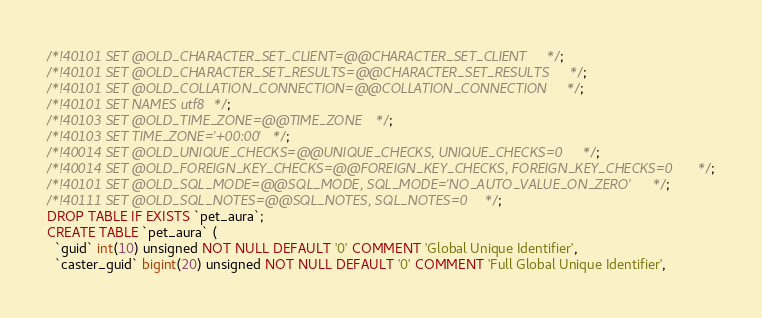<code> <loc_0><loc_0><loc_500><loc_500><_SQL_>
/*!40101 SET @OLD_CHARACTER_SET_CLIENT=@@CHARACTER_SET_CLIENT */;
/*!40101 SET @OLD_CHARACTER_SET_RESULTS=@@CHARACTER_SET_RESULTS */;
/*!40101 SET @OLD_COLLATION_CONNECTION=@@COLLATION_CONNECTION */;
/*!40101 SET NAMES utf8 */;
/*!40103 SET @OLD_TIME_ZONE=@@TIME_ZONE */;
/*!40103 SET TIME_ZONE='+00:00' */;
/*!40014 SET @OLD_UNIQUE_CHECKS=@@UNIQUE_CHECKS, UNIQUE_CHECKS=0 */;
/*!40014 SET @OLD_FOREIGN_KEY_CHECKS=@@FOREIGN_KEY_CHECKS, FOREIGN_KEY_CHECKS=0 */;
/*!40101 SET @OLD_SQL_MODE=@@SQL_MODE, SQL_MODE='NO_AUTO_VALUE_ON_ZERO' */;
/*!40111 SET @OLD_SQL_NOTES=@@SQL_NOTES, SQL_NOTES=0 */;
DROP TABLE IF EXISTS `pet_aura`;
CREATE TABLE `pet_aura` (
  `guid` int(10) unsigned NOT NULL DEFAULT '0' COMMENT 'Global Unique Identifier',
  `caster_guid` bigint(20) unsigned NOT NULL DEFAULT '0' COMMENT 'Full Global Unique Identifier',</code> 